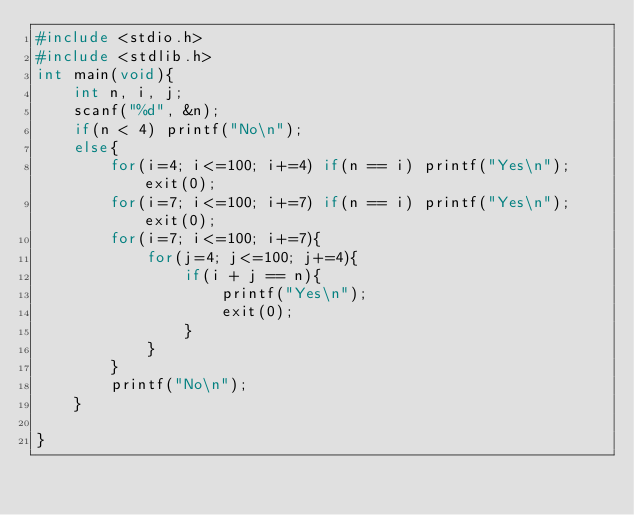Convert code to text. <code><loc_0><loc_0><loc_500><loc_500><_C_>#include <stdio.h>
#include <stdlib.h>
int main(void){
    int n, i, j;
    scanf("%d", &n);
    if(n < 4) printf("No\n");
    else{
        for(i=4; i<=100; i+=4) if(n == i) printf("Yes\n"); exit(0);
        for(i=7; i<=100; i+=7) if(n == i) printf("Yes\n"); exit(0);
        for(i=7; i<=100; i+=7){
            for(j=4; j<=100; j+=4){
                if(i + j == n){
                    printf("Yes\n");
                    exit(0);
                }
            }
        }
        printf("No\n");
    }
    
}
</code> 